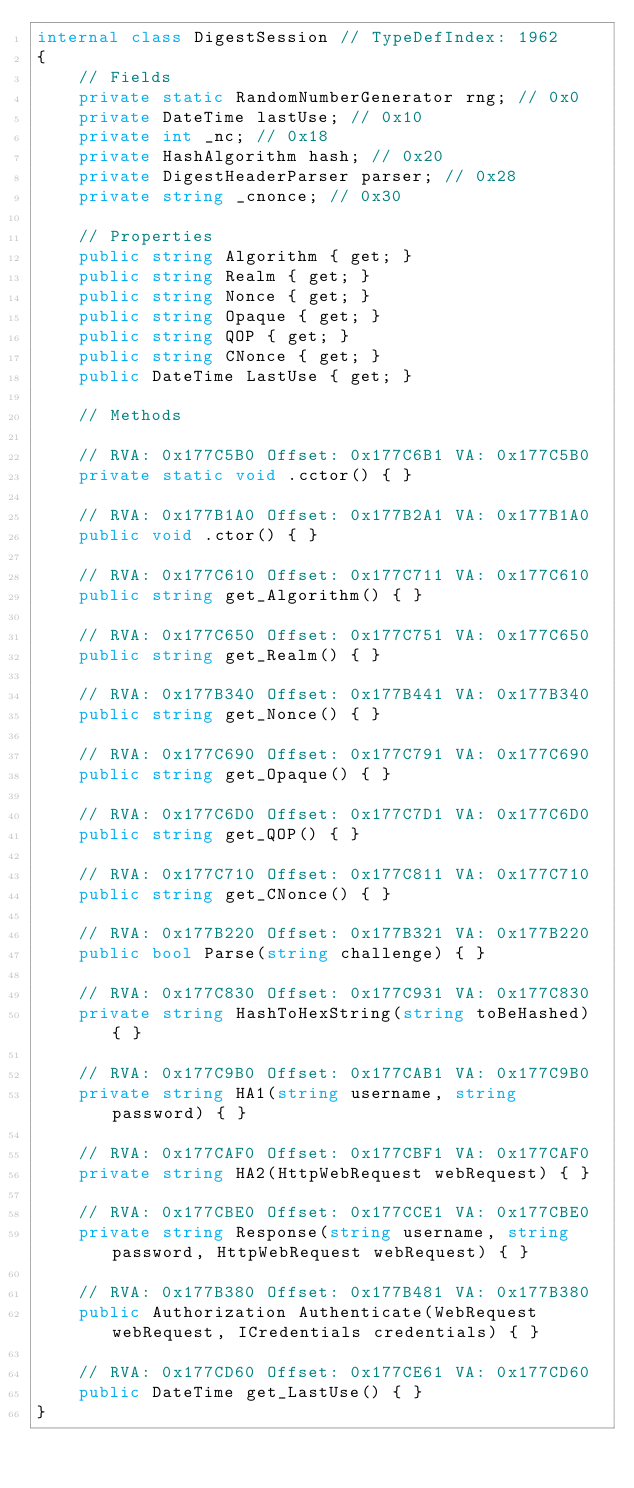Convert code to text. <code><loc_0><loc_0><loc_500><loc_500><_C#_>internal class DigestSession // TypeDefIndex: 1962
{
	// Fields
	private static RandomNumberGenerator rng; // 0x0
	private DateTime lastUse; // 0x10
	private int _nc; // 0x18
	private HashAlgorithm hash; // 0x20
	private DigestHeaderParser parser; // 0x28
	private string _cnonce; // 0x30

	// Properties
	public string Algorithm { get; }
	public string Realm { get; }
	public string Nonce { get; }
	public string Opaque { get; }
	public string QOP { get; }
	public string CNonce { get; }
	public DateTime LastUse { get; }

	// Methods

	// RVA: 0x177C5B0 Offset: 0x177C6B1 VA: 0x177C5B0
	private static void .cctor() { }

	// RVA: 0x177B1A0 Offset: 0x177B2A1 VA: 0x177B1A0
	public void .ctor() { }

	// RVA: 0x177C610 Offset: 0x177C711 VA: 0x177C610
	public string get_Algorithm() { }

	// RVA: 0x177C650 Offset: 0x177C751 VA: 0x177C650
	public string get_Realm() { }

	// RVA: 0x177B340 Offset: 0x177B441 VA: 0x177B340
	public string get_Nonce() { }

	// RVA: 0x177C690 Offset: 0x177C791 VA: 0x177C690
	public string get_Opaque() { }

	// RVA: 0x177C6D0 Offset: 0x177C7D1 VA: 0x177C6D0
	public string get_QOP() { }

	// RVA: 0x177C710 Offset: 0x177C811 VA: 0x177C710
	public string get_CNonce() { }

	// RVA: 0x177B220 Offset: 0x177B321 VA: 0x177B220
	public bool Parse(string challenge) { }

	// RVA: 0x177C830 Offset: 0x177C931 VA: 0x177C830
	private string HashToHexString(string toBeHashed) { }

	// RVA: 0x177C9B0 Offset: 0x177CAB1 VA: 0x177C9B0
	private string HA1(string username, string password) { }

	// RVA: 0x177CAF0 Offset: 0x177CBF1 VA: 0x177CAF0
	private string HA2(HttpWebRequest webRequest) { }

	// RVA: 0x177CBE0 Offset: 0x177CCE1 VA: 0x177CBE0
	private string Response(string username, string password, HttpWebRequest webRequest) { }

	// RVA: 0x177B380 Offset: 0x177B481 VA: 0x177B380
	public Authorization Authenticate(WebRequest webRequest, ICredentials credentials) { }

	// RVA: 0x177CD60 Offset: 0x177CE61 VA: 0x177CD60
	public DateTime get_LastUse() { }
}

</code> 